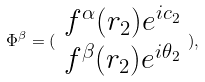<formula> <loc_0><loc_0><loc_500><loc_500>\Phi ^ { \beta } = ( \begin{array} { c } f ^ { \alpha } ( r _ { 2 } ) e ^ { i c _ { 2 } } \\ f ^ { \beta } ( r _ { 2 } ) e ^ { i \theta _ { 2 } } \end{array} ) ,</formula> 